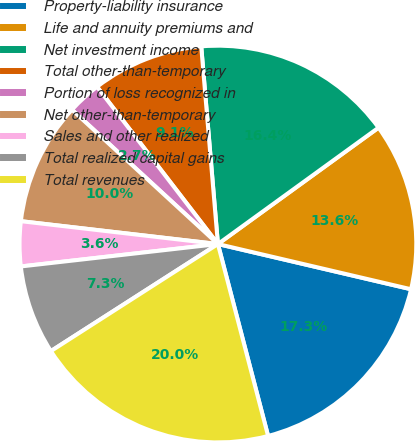<chart> <loc_0><loc_0><loc_500><loc_500><pie_chart><fcel>Property-liability insurance<fcel>Life and annuity premiums and<fcel>Net investment income<fcel>Total other-than-temporary<fcel>Portion of loss recognized in<fcel>Net other-than-temporary<fcel>Sales and other realized<fcel>Total realized capital gains<fcel>Total revenues<nl><fcel>17.27%<fcel>13.64%<fcel>16.36%<fcel>9.09%<fcel>2.73%<fcel>10.0%<fcel>3.64%<fcel>7.27%<fcel>20.0%<nl></chart> 